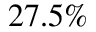Convert formula to latex. <formula><loc_0><loc_0><loc_500><loc_500>2 7 . 5 \%</formula> 